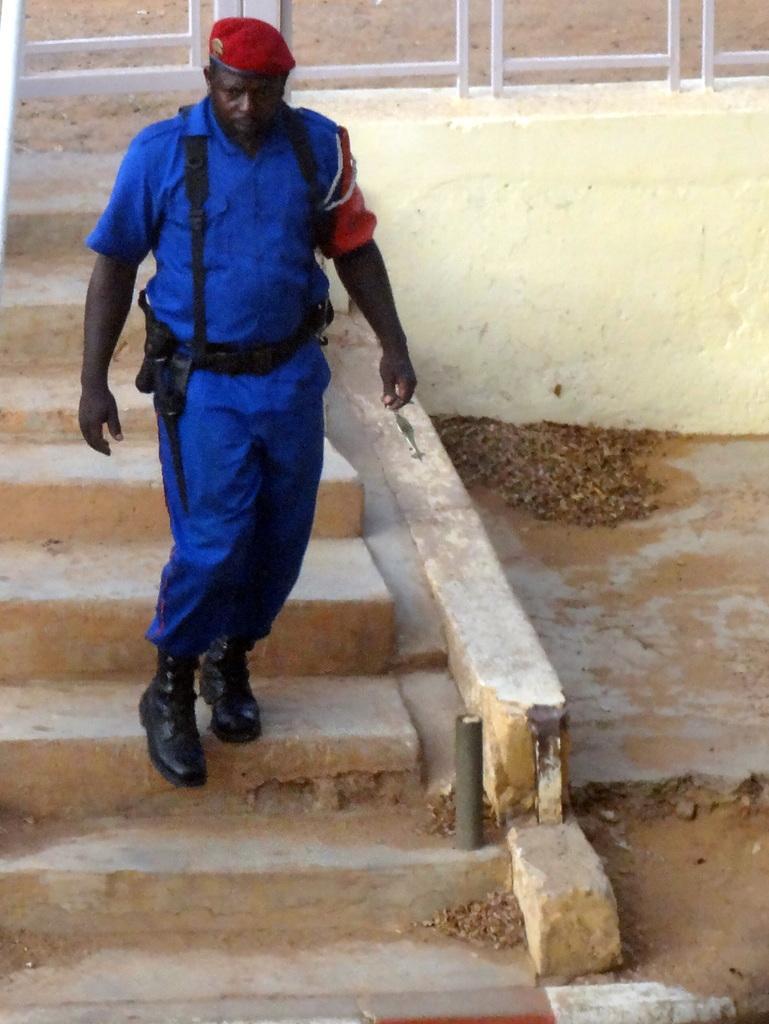Could you give a brief overview of what you see in this image? In this image in the center there is a man wearing a blue colour dress and red colour hat. In the background there are steps and there is a white colour fence. 